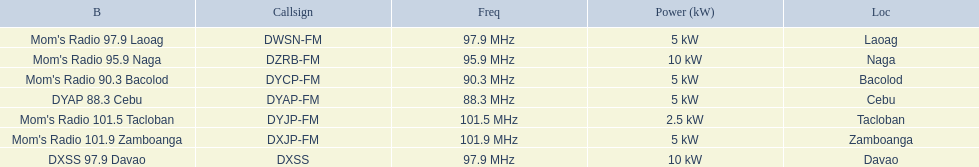Which stations use less than 10kw of power? Mom's Radio 97.9 Laoag, Mom's Radio 90.3 Bacolod, DYAP 88.3 Cebu, Mom's Radio 101.5 Tacloban, Mom's Radio 101.9 Zamboanga. Do any stations use less than 5kw of power? if so, which ones? Mom's Radio 101.5 Tacloban. 